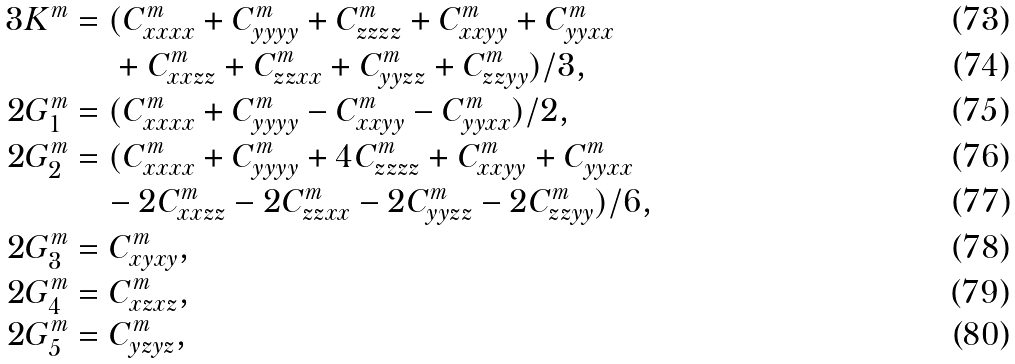Convert formula to latex. <formula><loc_0><loc_0><loc_500><loc_500>3 K ^ { m } & = ( C ^ { m } _ { x x x x } + C ^ { m } _ { y y y y } + C ^ { m } _ { z z z z } + C ^ { m } _ { x x y y } + C ^ { m } _ { y y x x } \\ & \quad \ + C ^ { m } _ { x x z z } + C ^ { m } _ { z z x x } + C ^ { m } _ { y y z z } + C ^ { m } _ { z z y y } ) / 3 , \\ 2 G ^ { m } _ { 1 } & = ( C ^ { m } _ { x x x x } + C ^ { m } _ { y y y y } - C ^ { m } _ { x x y y } - C ^ { m } _ { y y x x } ) / 2 , \\ 2 G ^ { m } _ { 2 } & = ( C ^ { m } _ { x x x x } + C ^ { m } _ { y y y y } + 4 C ^ { m } _ { z z z z } + C ^ { m } _ { x x y y } + C ^ { m } _ { y y x x } \\ & \quad - 2 C ^ { m } _ { x x z z } - 2 C ^ { m } _ { z z x x } - 2 C ^ { m } _ { y y z z } - 2 C ^ { m } _ { z z y y } ) / 6 , \\ 2 G ^ { m } _ { 3 } & = C ^ { m } _ { x y x y } , \\ 2 G ^ { m } _ { 4 } & = C ^ { m } _ { x z x z } , \\ 2 G ^ { m } _ { 5 } & = C ^ { m } _ { y z y z } ,</formula> 